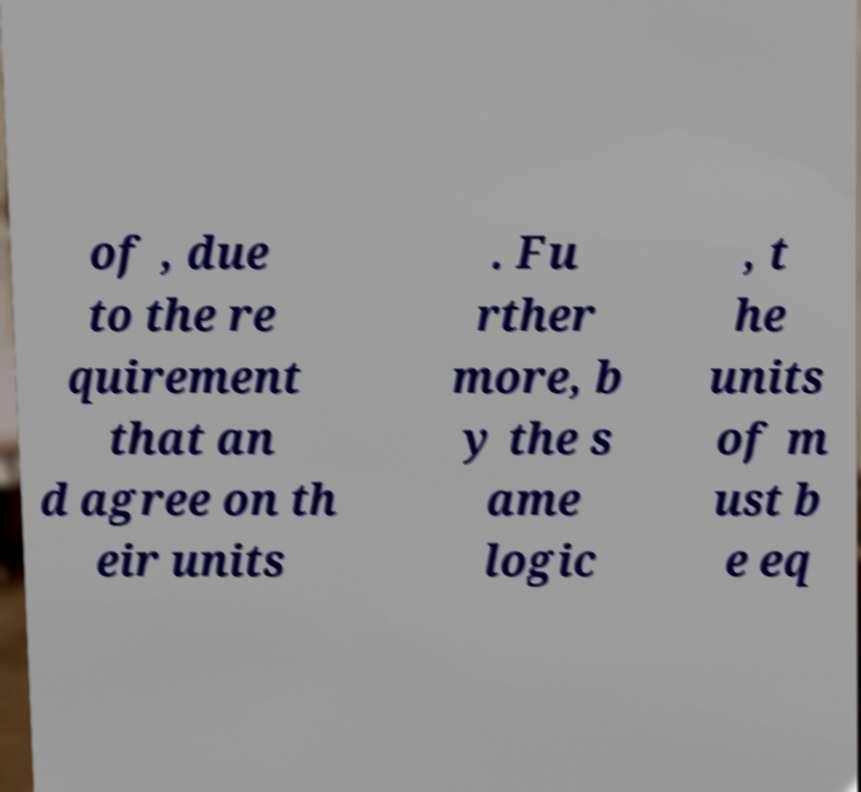For documentation purposes, I need the text within this image transcribed. Could you provide that? of , due to the re quirement that an d agree on th eir units . Fu rther more, b y the s ame logic , t he units of m ust b e eq 